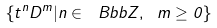Convert formula to latex. <formula><loc_0><loc_0><loc_500><loc_500>\{ t ^ { n } D ^ { m } | n \in \ B b b Z , \ m \geq 0 \}</formula> 